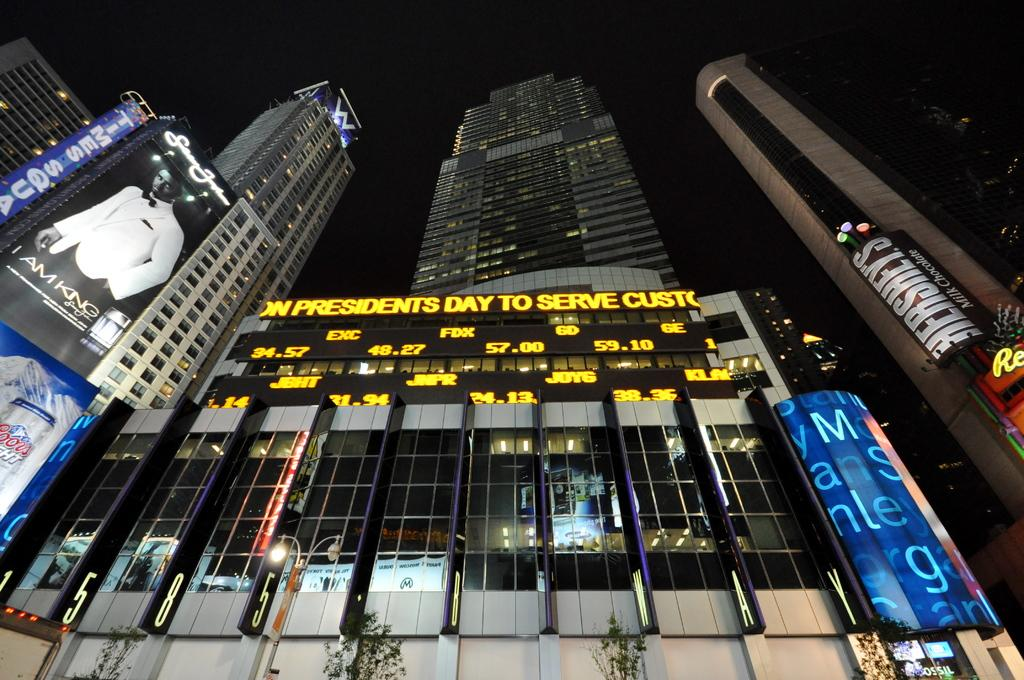What type of buildings can be seen in the image? There are skyscrapers in the image. What else can be seen on the buildings in the image? There are advertisements on the buildings in the image. What is visible in the background of the image? The sky is visible in the background of the image. What type of vegetation is at the bottom of the image? There are trees at the bottom of the image. What other objects can be seen at the bottom of the image? There are street poles and street lights at the bottom of the image. How many sheep are present in the image? There are no sheep present in the image. What type of pets can be seen in the image? There are no pets visible in the image. 